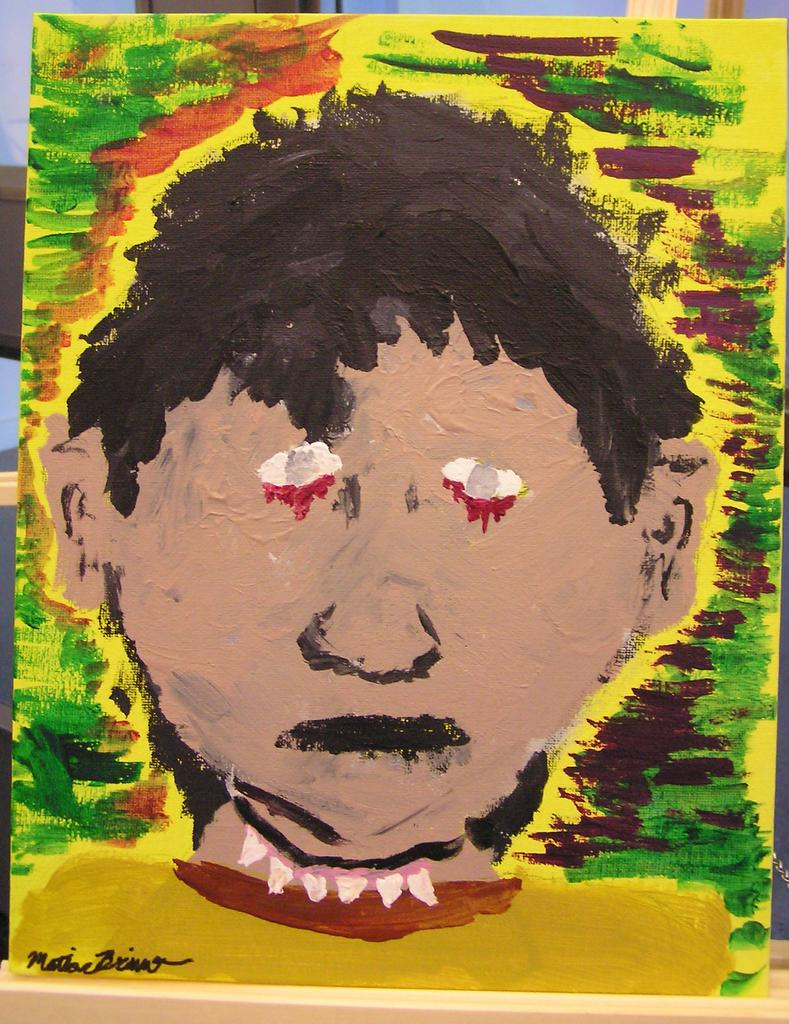What is the main subject of the image? There is a painting in the image. Can you describe any specific features of the painting? There is a watermark in the bottom left corner of the painting. What is supporting the painting in the image? There is a wooden stand behind the painting. What is visible behind the wooden stand? There is a wall behind the wooden stand. What is depicted in the painting? The painting depicts a person's face. What type of badge is attached to the person's nose in the painting? There is no badge attached to the person's nose in the painting; the painting only depicts a person's face. What color is the floor in the image? There is no floor visible in the image; the focus is on the painting, wooden stand, and wall. 